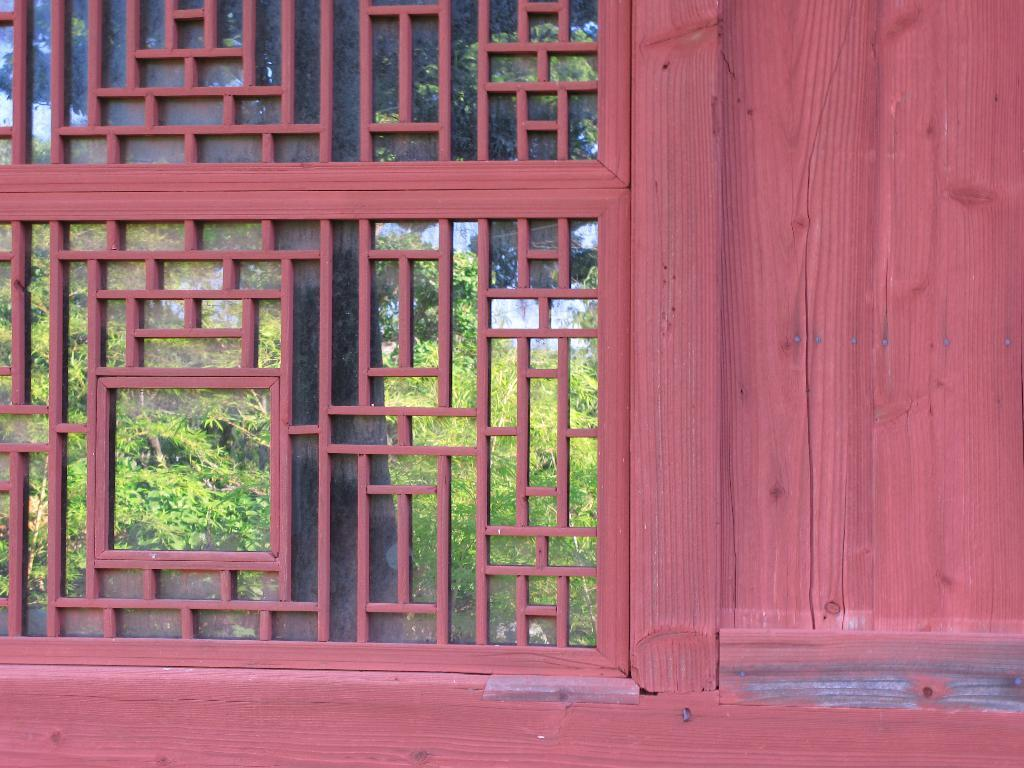What can be seen through the window in the image? Trees are visible through the window in the image. What type of wall is located beside the window? There is a wooden wall beside the window. Can you describe the window's position in the image? The window is a prominent feature in the image. What time does the clock show on the wall beside the window? There is no clock present on the wall beside the window in the image. 